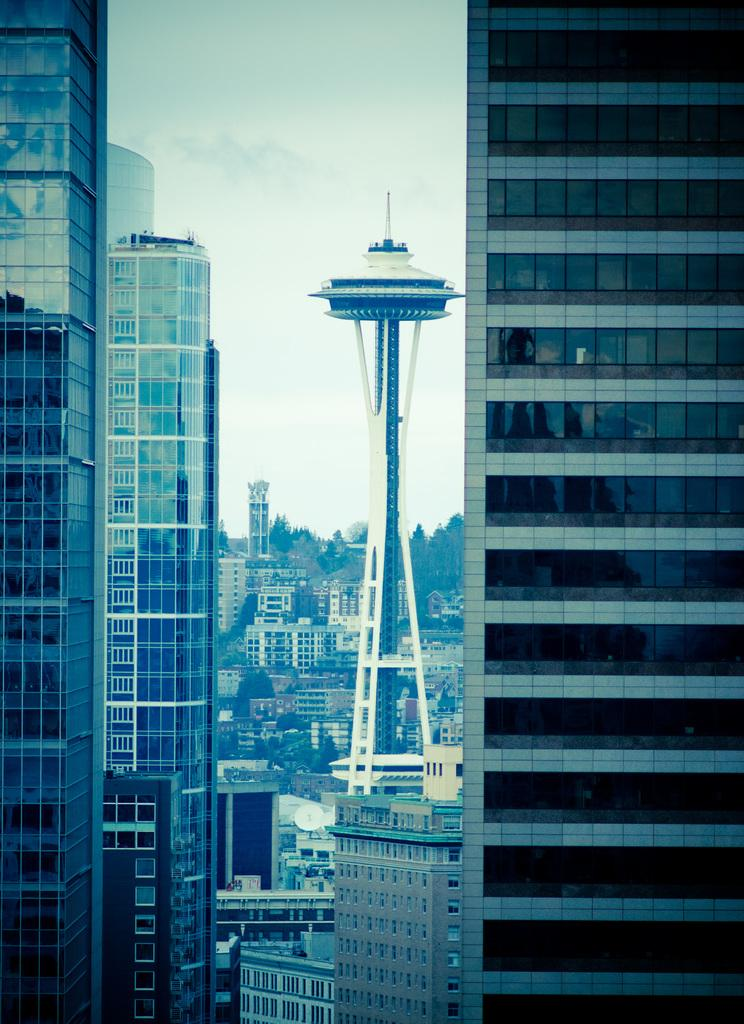What type of structures can be seen in the image? There are buildings in the image. What is the main feature in the center of the image? There is a tower in the center of the image. What can be seen in the background of the image? There are trees and the sky visible in the background of the image. What type of flesh can be seen on the buildings in the image? There is no flesh present on the buildings in the image; it features buildings, a tower, trees, and the sky. 